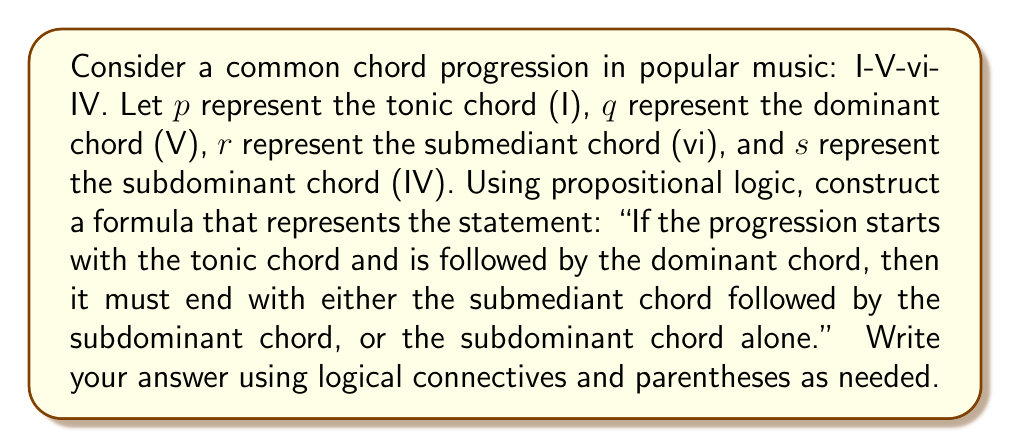Show me your answer to this math problem. To solve this problem, we need to break down the statement into its logical components and use propositional logic to construct the formula. Let's approach this step-by-step:

1. First, let's identify the individual propositions:
   p: The progression starts with the tonic chord (I)
   q: The progression is followed by the dominant chord (V)
   r: The progression includes the submediant chord (vi)
   s: The progression ends with the subdominant chord (IV)

2. Now, let's break down the statement:
   - "If the progression starts with the tonic chord and is followed by the dominant chord" 
     This can be represented as: $p \land q$

   - "then it must end with either the submediant chord followed by the subdominant chord, or the subdominant chord alone"
     This can be represented as: $(r \land s) \lor s$

3. Combining these parts using the implication connective ($\rightarrow$), we get:

   $$(p \land q) \rightarrow ((r \land s) \lor s)$$

4. This formula can be read as: "If p and q, then (r and s) or s"

5. In the context of music theory, this logical structure represents the idea that if a progression begins with I-V, it should conclude with either vi-IV or just IV, which is a common pattern in many popular songs.
Answer: $$(p \land q) \rightarrow ((r \land s) \lor s)$$ 